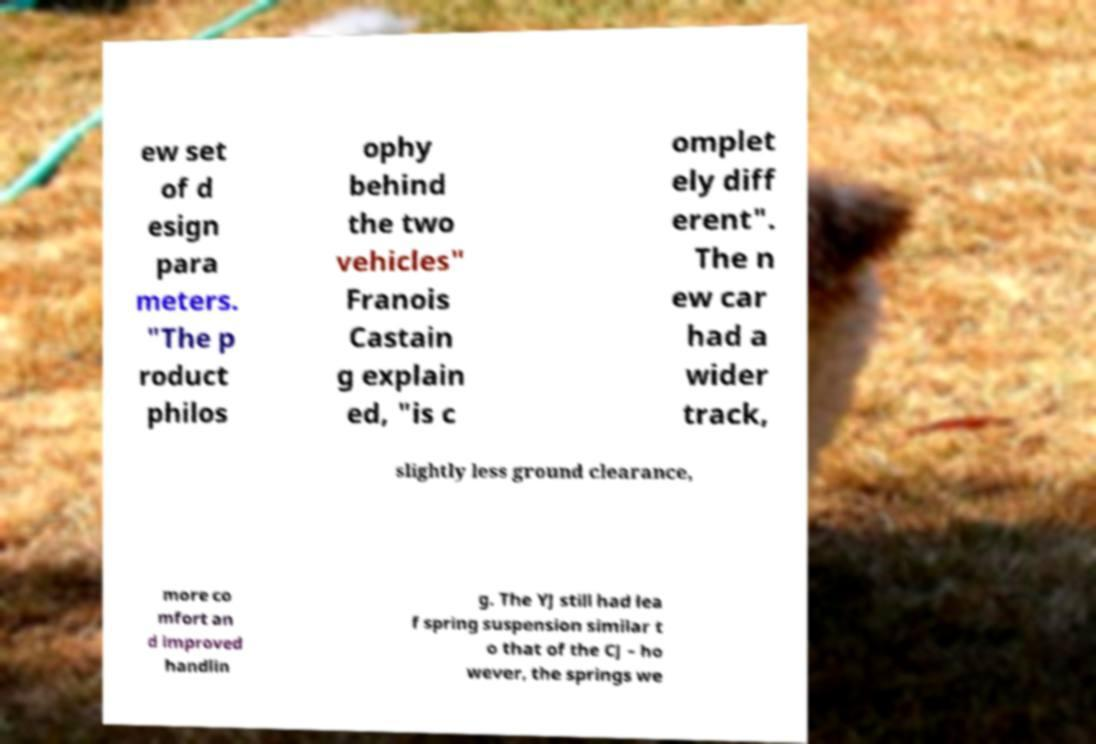Please read and relay the text visible in this image. What does it say? ew set of d esign para meters. "The p roduct philos ophy behind the two vehicles" Franois Castain g explain ed, "is c omplet ely diff erent". The n ew car had a wider track, slightly less ground clearance, more co mfort an d improved handlin g. The YJ still had lea f spring suspension similar t o that of the CJ – ho wever, the springs we 